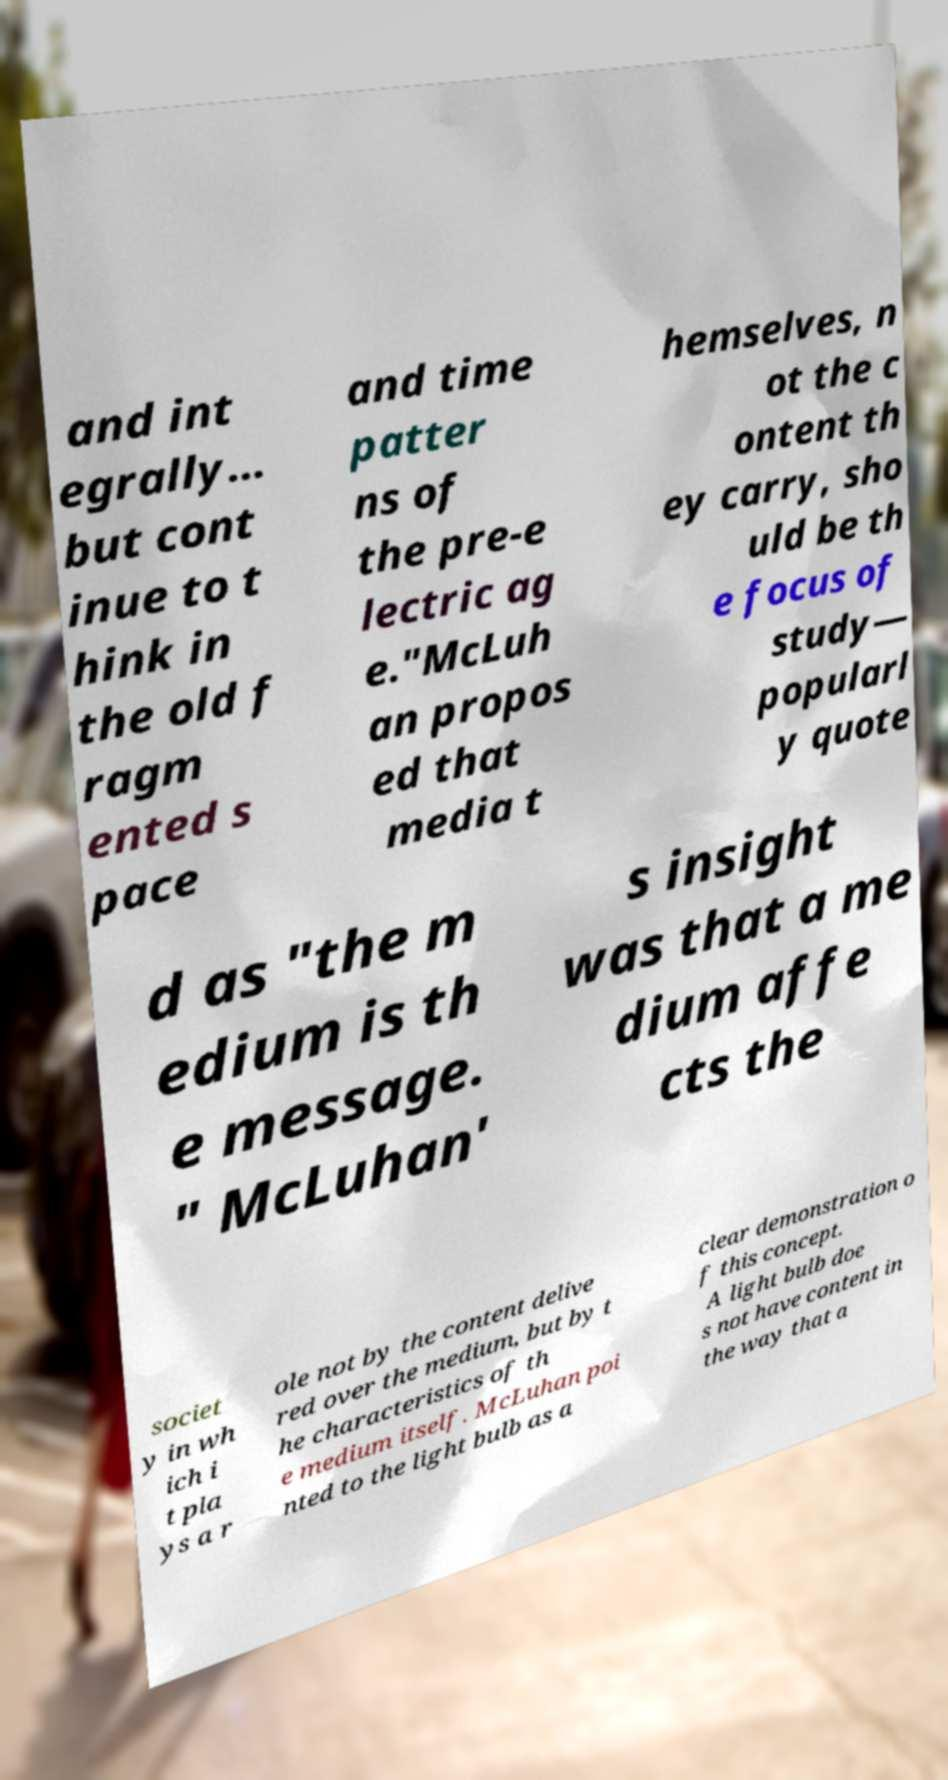What messages or text are displayed in this image? I need them in a readable, typed format. and int egrally… but cont inue to t hink in the old f ragm ented s pace and time patter ns of the pre-e lectric ag e."McLuh an propos ed that media t hemselves, n ot the c ontent th ey carry, sho uld be th e focus of study— popularl y quote d as "the m edium is th e message. " McLuhan' s insight was that a me dium affe cts the societ y in wh ich i t pla ys a r ole not by the content delive red over the medium, but by t he characteristics of th e medium itself. McLuhan poi nted to the light bulb as a clear demonstration o f this concept. A light bulb doe s not have content in the way that a 